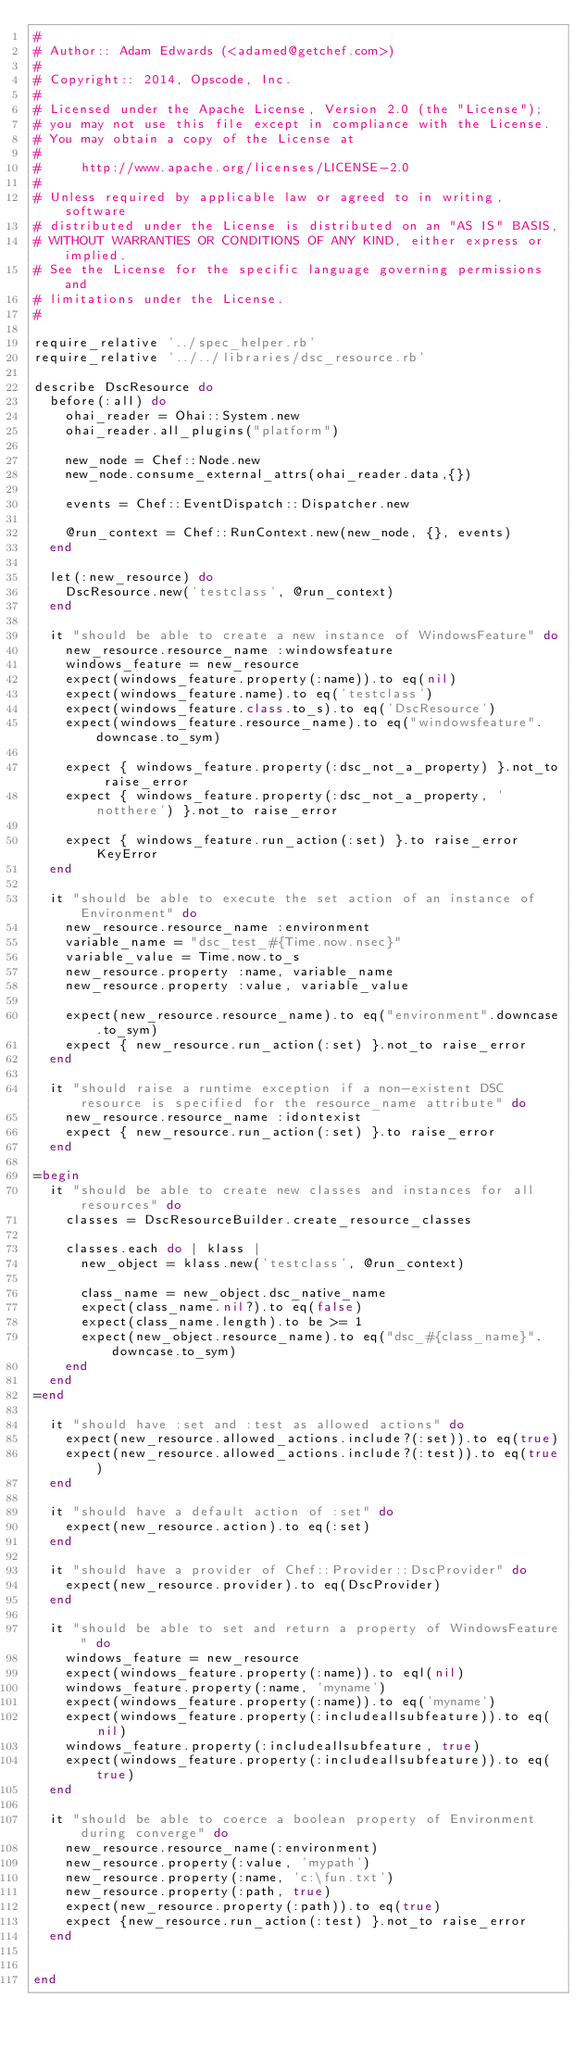<code> <loc_0><loc_0><loc_500><loc_500><_Ruby_>#
# Author:: Adam Edwards (<adamed@getchef.com>)
#
# Copyright:: 2014, Opscode, Inc.
#
# Licensed under the Apache License, Version 2.0 (the "License");
# you may not use this file except in compliance with the License.
# You may obtain a copy of the License at
#
#     http://www.apache.org/licenses/LICENSE-2.0
#
# Unless required by applicable law or agreed to in writing, software
# distributed under the License is distributed on an "AS IS" BASIS,
# WITHOUT WARRANTIES OR CONDITIONS OF ANY KIND, either express or implied.
# See the License for the specific language governing permissions and
# limitations under the License.
#

require_relative '../spec_helper.rb'
require_relative '../../libraries/dsc_resource.rb'

describe DscResource do
  before(:all) do
    ohai_reader = Ohai::System.new
    ohai_reader.all_plugins("platform")

    new_node = Chef::Node.new
    new_node.consume_external_attrs(ohai_reader.data,{})

    events = Chef::EventDispatch::Dispatcher.new

    @run_context = Chef::RunContext.new(new_node, {}, events)
  end

  let(:new_resource) do
    DscResource.new('testclass', @run_context)
  end

  it "should be able to create a new instance of WindowsFeature" do
    new_resource.resource_name :windowsfeature
    windows_feature = new_resource
    expect(windows_feature.property(:name)).to eq(nil)
    expect(windows_feature.name).to eq('testclass')
    expect(windows_feature.class.to_s).to eq('DscResource')
    expect(windows_feature.resource_name).to eq("windowsfeature".downcase.to_sym)

    expect { windows_feature.property(:dsc_not_a_property) }.not_to raise_error
    expect { windows_feature.property(:dsc_not_a_property, 'notthere') }.not_to raise_error

    expect { windows_feature.run_action(:set) }.to raise_error KeyError
  end

  it "should be able to execute the set action of an instance of Environment" do
    new_resource.resource_name :environment
    variable_name = "dsc_test_#{Time.now.nsec}"
    variable_value = Time.now.to_s
    new_resource.property :name, variable_name
    new_resource.property :value, variable_value

    expect(new_resource.resource_name).to eq("environment".downcase.to_sym)
    expect { new_resource.run_action(:set) }.not_to raise_error
  end

  it "should raise a runtime exception if a non-existent DSC resource is specified for the resource_name attribute" do
    new_resource.resource_name :idontexist
    expect { new_resource.run_action(:set) }.to raise_error
  end

=begin
  it "should be able to create new classes and instances for all resources" do
    classes = DscResourceBuilder.create_resource_classes

    classes.each do | klass |
      new_object = klass.new('testclass', @run_context)
      
      class_name = new_object.dsc_native_name
      expect(class_name.nil?).to eq(false)
      expect(class_name.length).to be >= 1
      expect(new_object.resource_name).to eq("dsc_#{class_name}".downcase.to_sym)
    end
  end
=end

  it "should have :set and :test as allowed actions" do
    expect(new_resource.allowed_actions.include?(:set)).to eq(true)
    expect(new_resource.allowed_actions.include?(:test)).to eq(true)
  end

  it "should have a default action of :set" do
    expect(new_resource.action).to eq(:set)
  end

  it "should have a provider of Chef::Provider::DscProvider" do
    expect(new_resource.provider).to eq(DscProvider)
  end

  it "should be able to set and return a property of WindowsFeature" do
    windows_feature = new_resource
    expect(windows_feature.property(:name)).to eql(nil)
    windows_feature.property(:name, 'myname')
    expect(windows_feature.property(:name)).to eq('myname')
    expect(windows_feature.property(:includeallsubfeature)).to eq(nil)
    windows_feature.property(:includeallsubfeature, true)
    expect(windows_feature.property(:includeallsubfeature)).to eq(true)
  end

  it "should be able to coerce a boolean property of Environment during converge" do
    new_resource.resource_name(:environment)
    new_resource.property(:value, 'mypath')
    new_resource.property(:name, 'c:\fun.txt')
    new_resource.property(:path, true)
    expect(new_resource.property(:path)).to eq(true)
    expect {new_resource.run_action(:test) }.not_to raise_error
  end


end


</code> 